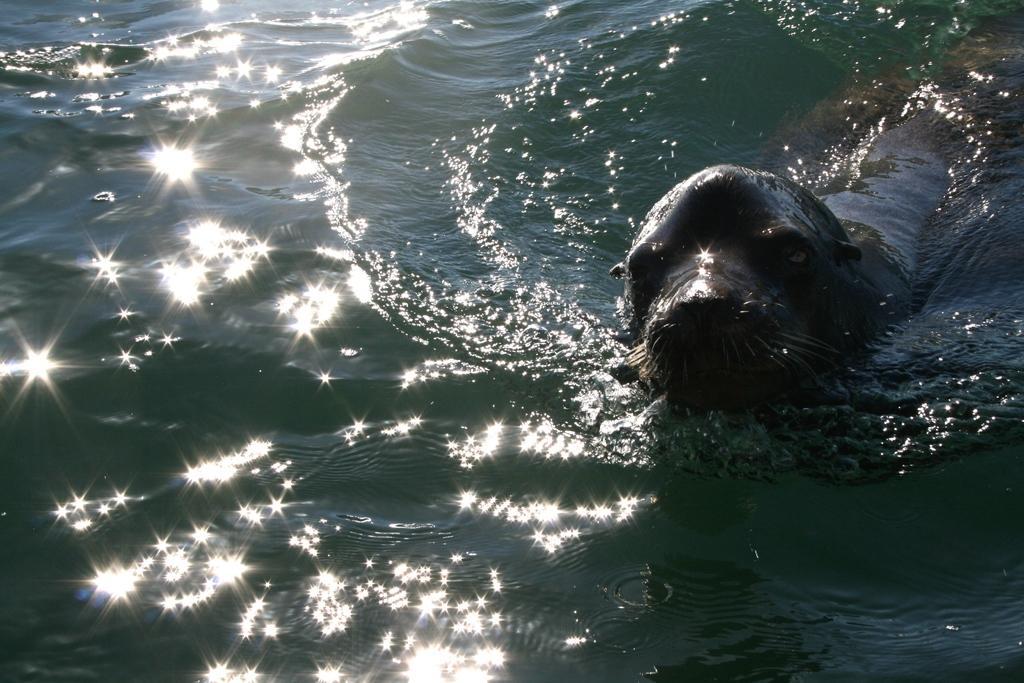Describe this image in one or two sentences. In this picture we can see a sea animal in water. 